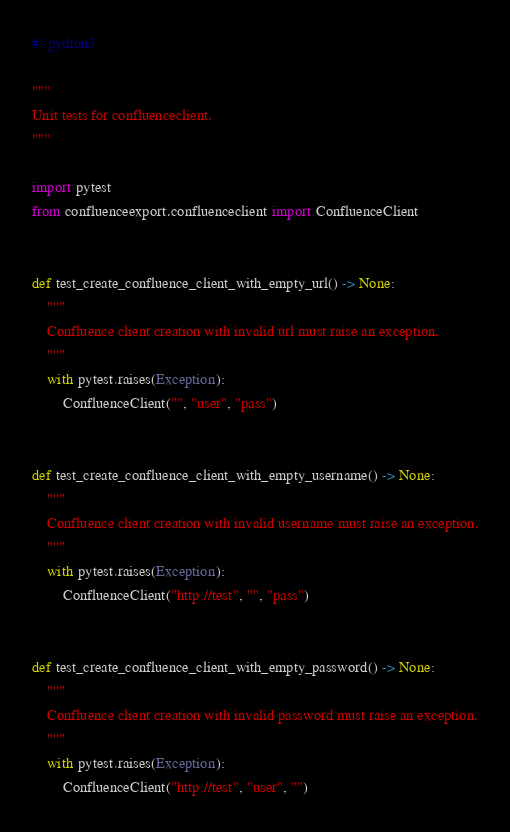<code> <loc_0><loc_0><loc_500><loc_500><_Python_>#! python3

"""
Unit tests for confluenceclient.
"""

import pytest
from confluenceexport.confluenceclient import ConfluenceClient


def test_create_confluence_client_with_empty_url() -> None:
    """
    Confluence client creation with invalid url must raise an exception.
    """
    with pytest.raises(Exception):
        ConfluenceClient("", "user", "pass")


def test_create_confluence_client_with_empty_username() -> None:
    """
    Confluence client creation with invalid username must raise an exception.
    """
    with pytest.raises(Exception):
        ConfluenceClient("http://test", "", "pass")


def test_create_confluence_client_with_empty_password() -> None:
    """
    Confluence client creation with invalid password must raise an exception.
    """
    with pytest.raises(Exception):
        ConfluenceClient("http://test", "user", "")
</code> 